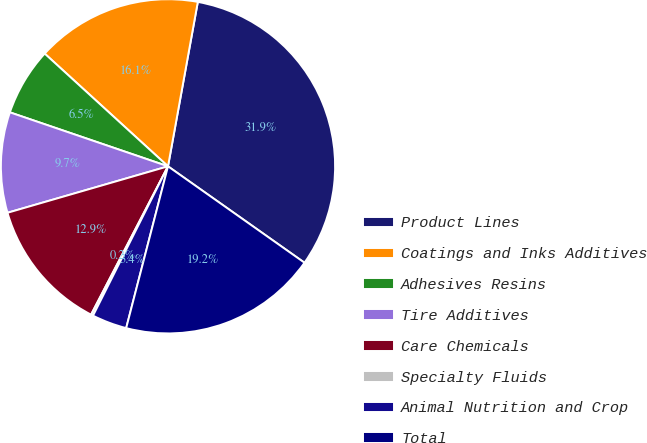Convert chart. <chart><loc_0><loc_0><loc_500><loc_500><pie_chart><fcel>Product Lines<fcel>Coatings and Inks Additives<fcel>Adhesives Resins<fcel>Tire Additives<fcel>Care Chemicals<fcel>Specialty Fluids<fcel>Animal Nutrition and Crop<fcel>Total<nl><fcel>31.93%<fcel>16.07%<fcel>6.55%<fcel>9.72%<fcel>12.9%<fcel>0.21%<fcel>3.38%<fcel>19.24%<nl></chart> 